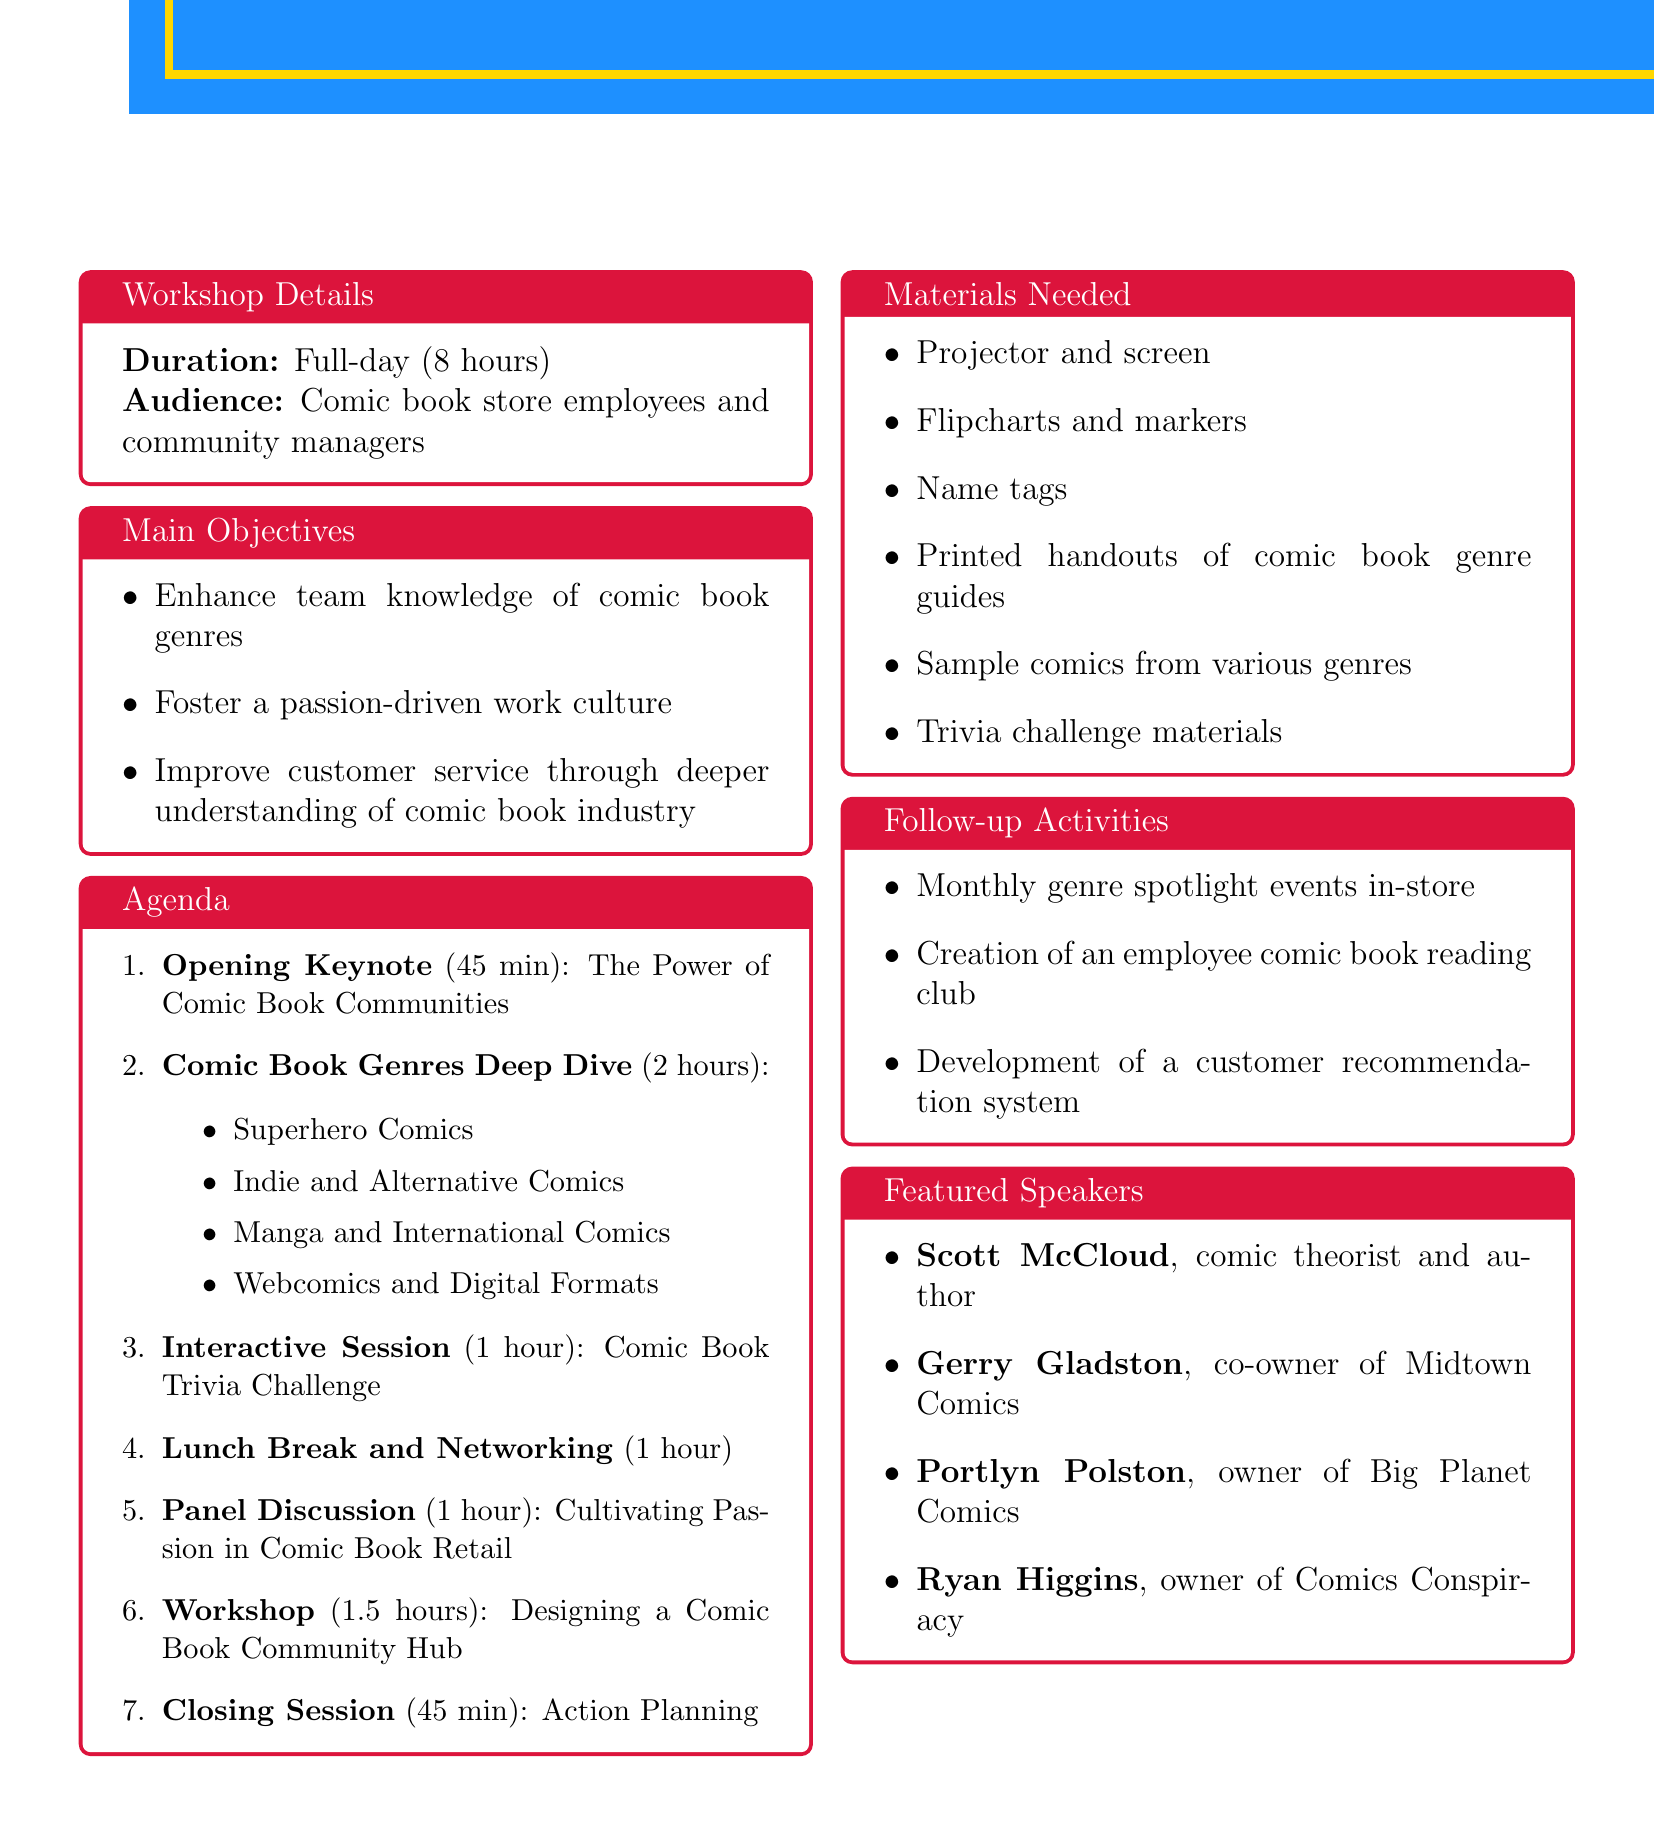what is the title of the workshop? The title of the workshop is explicitly stated in the document as "Comic Book Passion: Uniting Team Knowledge and Culture."
Answer: Comic Book Passion: Uniting Team Knowledge and Culture how long is the workshop? The duration of the workshop is mentioned directly as "Full-day (8 hours)."
Answer: Full-day (8 hours) who is the speaker for the opening keynote? The document specifies that Scott McCloud is the speaker for the opening keynote.
Answer: Scott McCloud how many hours is the "Comic Book Genres Deep Dive" session? The workshop agenda lists the duration of the "Comic Book Genres Deep Dive" session as 2 hours.
Answer: 2 hours what are the names of the panelists in the discussion? The document includes the names of the panelists: Gerry Gladston, Portlyn Polston, and Ryan Higgins.
Answer: Gerry Gladston, Portlyn Polston, Ryan Higgins what activity is scheduled for the afternoon after lunch? The agenda clearly states that the activity following lunch is a panel discussion titled "Cultivating Passion in Comic Book Retail."
Answer: Panel Discussion which materials are needed for trivia challenges? The materials needed for trivia challenges are specifically listed as "Trivia challenge materials (questions, answer sheets, prizes)."
Answer: Trivia challenge materials what is one follow-up activity mentioned in the document? The document provides follow-up activities, one of which is the "Creation of an employee comic book reading club."
Answer: Creation of an employee comic book reading club how long is the closing session? The duration of the closing session is specifically mentioned as 45 minutes.
Answer: 45 minutes 